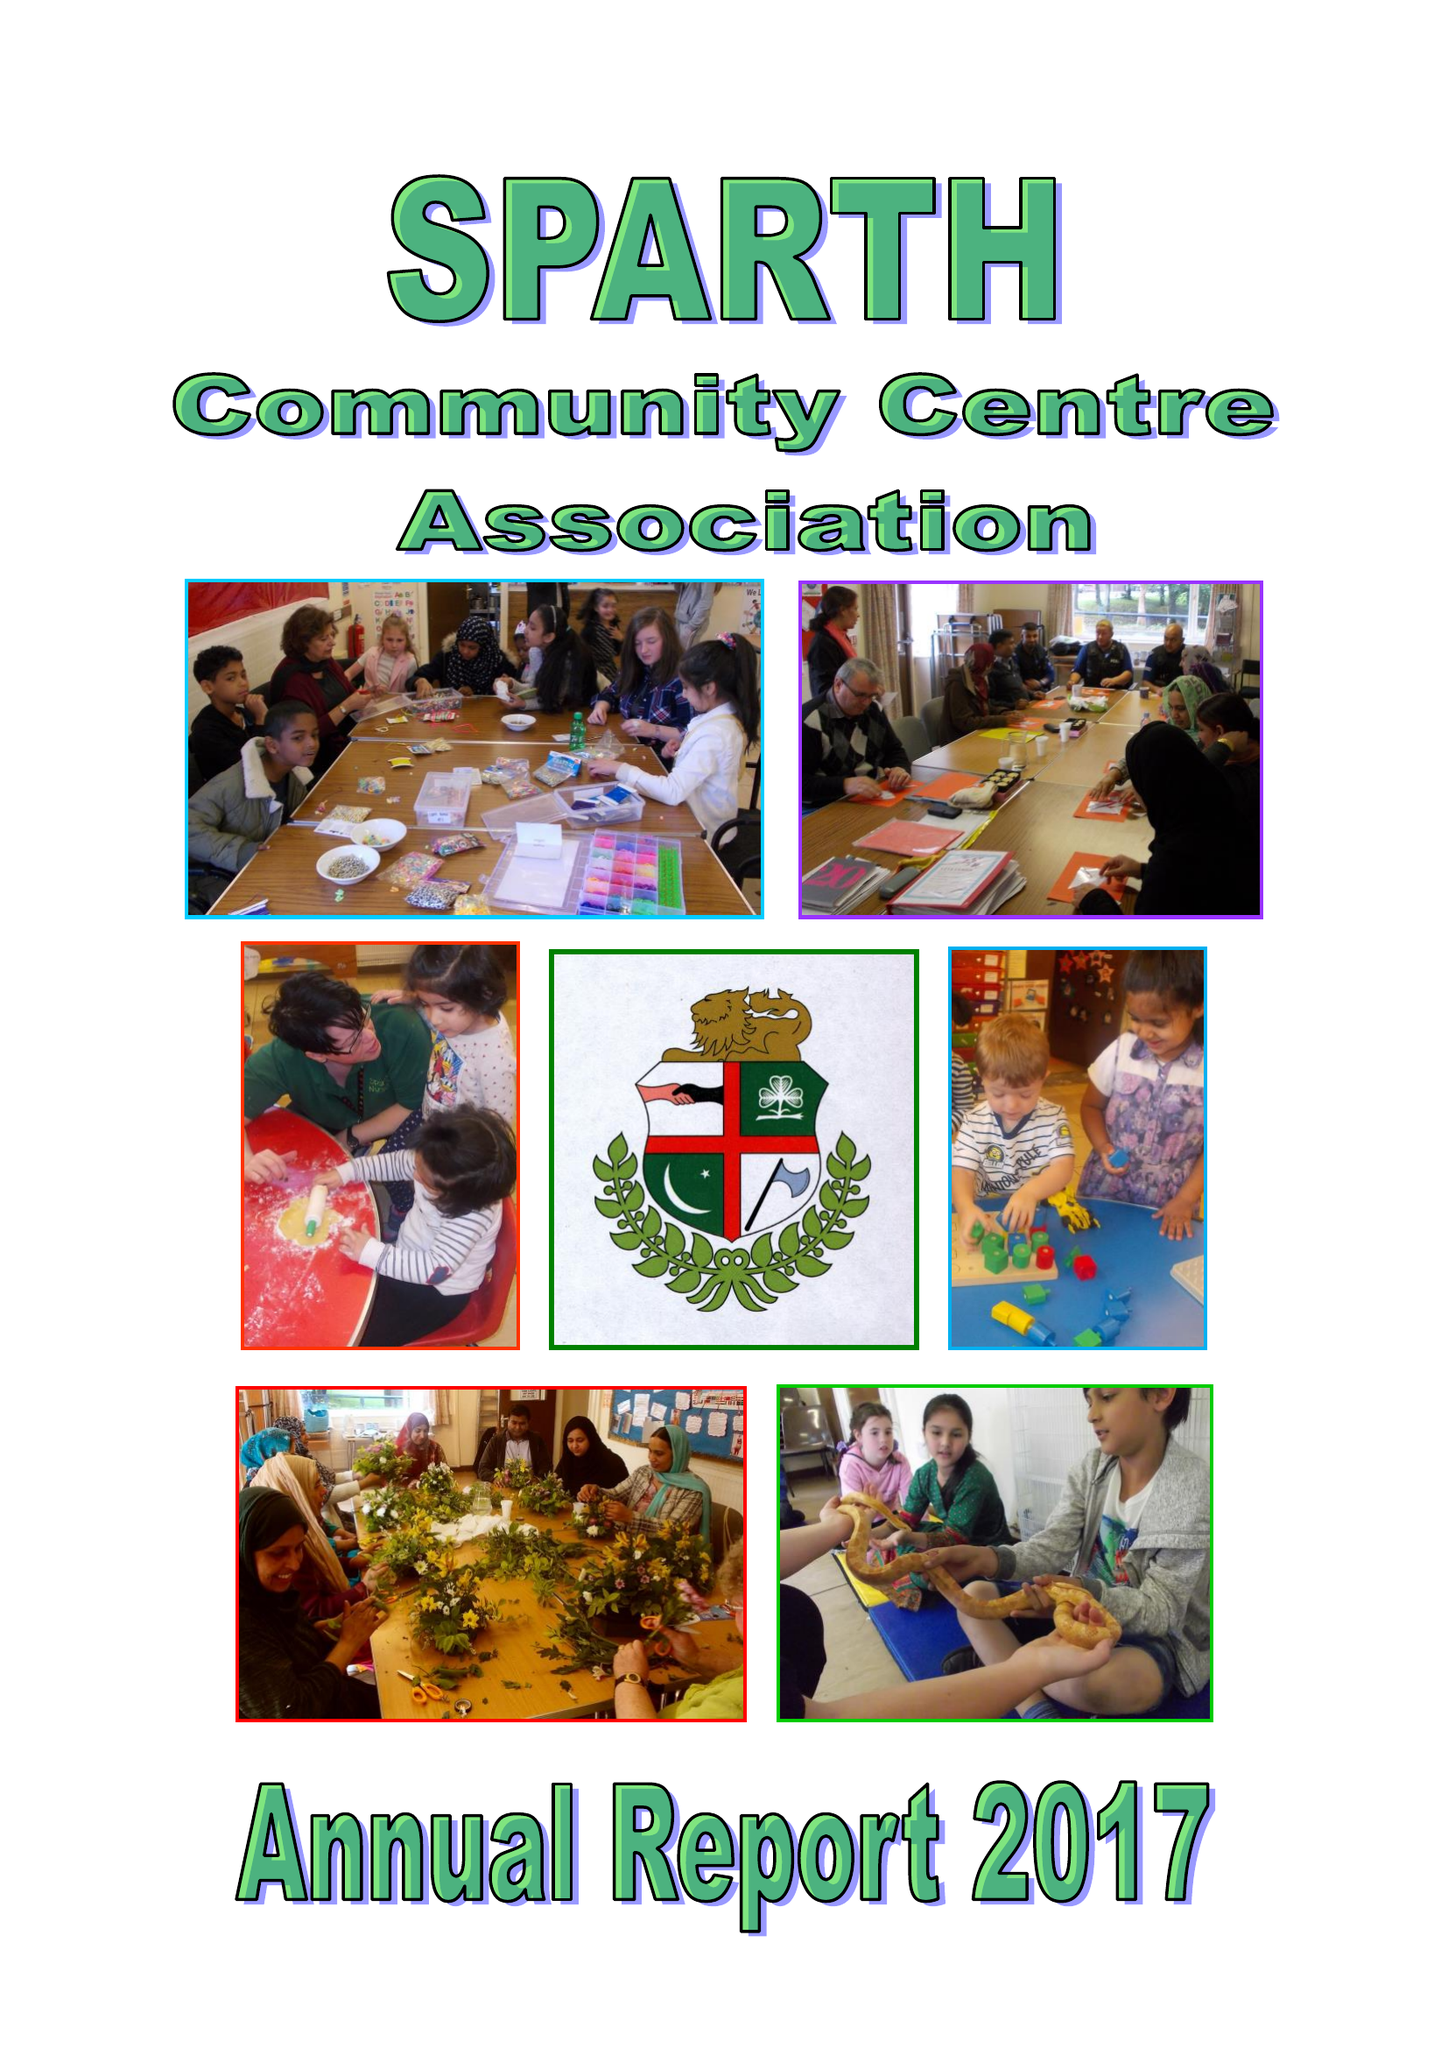What is the value for the address__postcode?
Answer the question using a single word or phrase. OL11 4HS 